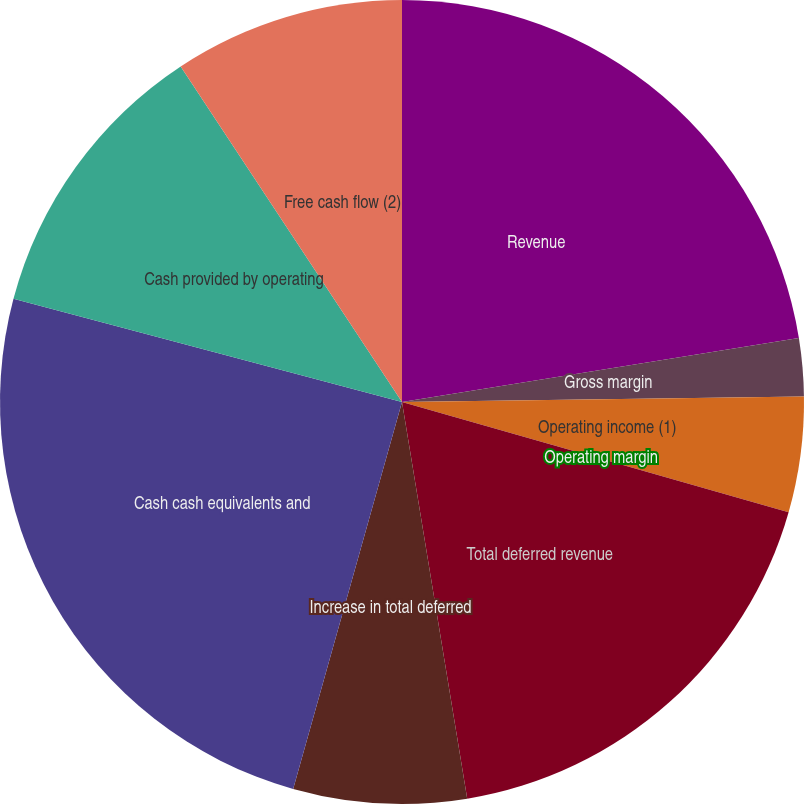<chart> <loc_0><loc_0><loc_500><loc_500><pie_chart><fcel>Revenue<fcel>Gross margin<fcel>Operating income (1)<fcel>Operating margin<fcel>Total deferred revenue<fcel>Increase in total deferred<fcel>Cash cash equivalents and<fcel>Cash provided by operating<fcel>Free cash flow (2)<nl><fcel>22.46%<fcel>2.32%<fcel>4.64%<fcel>0.0%<fcel>17.99%<fcel>6.96%<fcel>24.77%<fcel>11.59%<fcel>9.28%<nl></chart> 